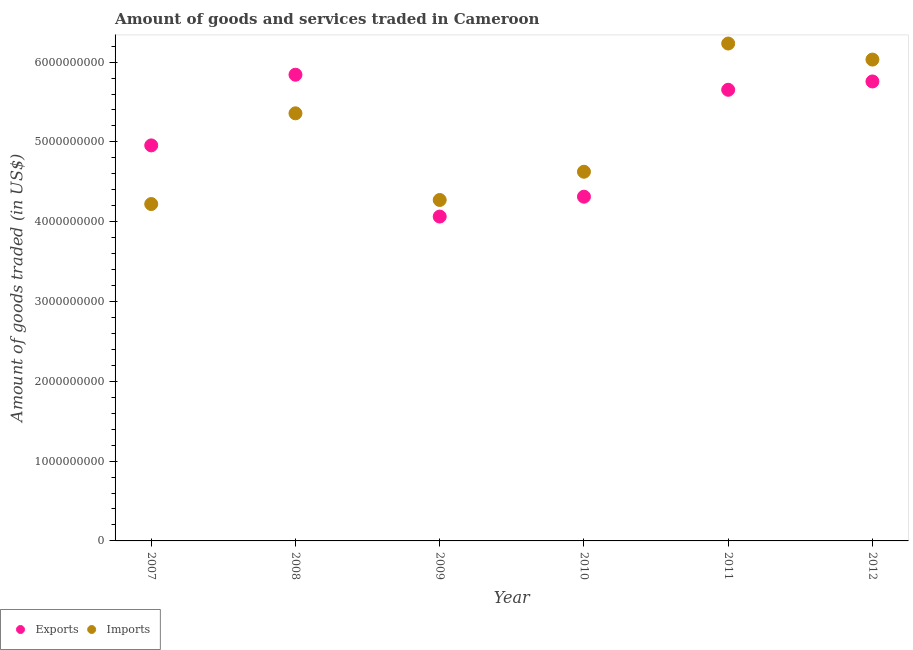How many different coloured dotlines are there?
Offer a terse response. 2. Is the number of dotlines equal to the number of legend labels?
Keep it short and to the point. Yes. What is the amount of goods exported in 2008?
Provide a short and direct response. 5.84e+09. Across all years, what is the maximum amount of goods exported?
Ensure brevity in your answer.  5.84e+09. Across all years, what is the minimum amount of goods imported?
Give a very brief answer. 4.22e+09. What is the total amount of goods exported in the graph?
Make the answer very short. 3.06e+1. What is the difference between the amount of goods exported in 2010 and that in 2012?
Provide a succinct answer. -1.44e+09. What is the difference between the amount of goods imported in 2011 and the amount of goods exported in 2008?
Provide a succinct answer. 3.91e+08. What is the average amount of goods imported per year?
Provide a succinct answer. 5.12e+09. In the year 2010, what is the difference between the amount of goods exported and amount of goods imported?
Your answer should be very brief. -3.13e+08. What is the ratio of the amount of goods imported in 2008 to that in 2010?
Provide a succinct answer. 1.16. Is the amount of goods imported in 2009 less than that in 2010?
Offer a very short reply. Yes. What is the difference between the highest and the second highest amount of goods exported?
Provide a succinct answer. 8.45e+07. What is the difference between the highest and the lowest amount of goods imported?
Offer a terse response. 2.01e+09. In how many years, is the amount of goods exported greater than the average amount of goods exported taken over all years?
Your answer should be compact. 3. Is the sum of the amount of goods imported in 2008 and 2011 greater than the maximum amount of goods exported across all years?
Make the answer very short. Yes. Where does the legend appear in the graph?
Provide a short and direct response. Bottom left. How are the legend labels stacked?
Your answer should be very brief. Horizontal. What is the title of the graph?
Ensure brevity in your answer.  Amount of goods and services traded in Cameroon. What is the label or title of the X-axis?
Provide a succinct answer. Year. What is the label or title of the Y-axis?
Provide a succinct answer. Amount of goods traded (in US$). What is the Amount of goods traded (in US$) in Exports in 2007?
Your answer should be compact. 4.96e+09. What is the Amount of goods traded (in US$) in Imports in 2007?
Keep it short and to the point. 4.22e+09. What is the Amount of goods traded (in US$) of Exports in 2008?
Give a very brief answer. 5.84e+09. What is the Amount of goods traded (in US$) in Imports in 2008?
Make the answer very short. 5.36e+09. What is the Amount of goods traded (in US$) of Exports in 2009?
Offer a very short reply. 4.06e+09. What is the Amount of goods traded (in US$) in Imports in 2009?
Provide a succinct answer. 4.27e+09. What is the Amount of goods traded (in US$) of Exports in 2010?
Make the answer very short. 4.31e+09. What is the Amount of goods traded (in US$) in Imports in 2010?
Offer a very short reply. 4.63e+09. What is the Amount of goods traded (in US$) in Exports in 2011?
Your answer should be very brief. 5.65e+09. What is the Amount of goods traded (in US$) of Imports in 2011?
Provide a succinct answer. 6.23e+09. What is the Amount of goods traded (in US$) in Exports in 2012?
Keep it short and to the point. 5.76e+09. What is the Amount of goods traded (in US$) in Imports in 2012?
Your response must be concise. 6.03e+09. Across all years, what is the maximum Amount of goods traded (in US$) in Exports?
Provide a short and direct response. 5.84e+09. Across all years, what is the maximum Amount of goods traded (in US$) of Imports?
Your answer should be very brief. 6.23e+09. Across all years, what is the minimum Amount of goods traded (in US$) of Exports?
Your answer should be very brief. 4.06e+09. Across all years, what is the minimum Amount of goods traded (in US$) in Imports?
Your answer should be very brief. 4.22e+09. What is the total Amount of goods traded (in US$) of Exports in the graph?
Offer a very short reply. 3.06e+1. What is the total Amount of goods traded (in US$) in Imports in the graph?
Make the answer very short. 3.07e+1. What is the difference between the Amount of goods traded (in US$) in Exports in 2007 and that in 2008?
Your answer should be very brief. -8.86e+08. What is the difference between the Amount of goods traded (in US$) in Imports in 2007 and that in 2008?
Ensure brevity in your answer.  -1.14e+09. What is the difference between the Amount of goods traded (in US$) of Exports in 2007 and that in 2009?
Provide a succinct answer. 8.92e+08. What is the difference between the Amount of goods traded (in US$) in Imports in 2007 and that in 2009?
Provide a succinct answer. -5.08e+07. What is the difference between the Amount of goods traded (in US$) in Exports in 2007 and that in 2010?
Your answer should be very brief. 6.43e+08. What is the difference between the Amount of goods traded (in US$) in Imports in 2007 and that in 2010?
Provide a short and direct response. -4.05e+08. What is the difference between the Amount of goods traded (in US$) of Exports in 2007 and that in 2011?
Provide a short and direct response. -6.97e+08. What is the difference between the Amount of goods traded (in US$) in Imports in 2007 and that in 2011?
Keep it short and to the point. -2.01e+09. What is the difference between the Amount of goods traded (in US$) in Exports in 2007 and that in 2012?
Provide a short and direct response. -8.01e+08. What is the difference between the Amount of goods traded (in US$) of Imports in 2007 and that in 2012?
Your answer should be compact. -1.81e+09. What is the difference between the Amount of goods traded (in US$) of Exports in 2008 and that in 2009?
Your answer should be compact. 1.78e+09. What is the difference between the Amount of goods traded (in US$) of Imports in 2008 and that in 2009?
Your response must be concise. 1.09e+09. What is the difference between the Amount of goods traded (in US$) in Exports in 2008 and that in 2010?
Your response must be concise. 1.53e+09. What is the difference between the Amount of goods traded (in US$) in Imports in 2008 and that in 2010?
Your answer should be very brief. 7.32e+08. What is the difference between the Amount of goods traded (in US$) of Exports in 2008 and that in 2011?
Your response must be concise. 1.89e+08. What is the difference between the Amount of goods traded (in US$) of Imports in 2008 and that in 2011?
Offer a very short reply. -8.75e+08. What is the difference between the Amount of goods traded (in US$) in Exports in 2008 and that in 2012?
Keep it short and to the point. 8.45e+07. What is the difference between the Amount of goods traded (in US$) of Imports in 2008 and that in 2012?
Make the answer very short. -6.73e+08. What is the difference between the Amount of goods traded (in US$) in Exports in 2009 and that in 2010?
Make the answer very short. -2.49e+08. What is the difference between the Amount of goods traded (in US$) in Imports in 2009 and that in 2010?
Offer a very short reply. -3.54e+08. What is the difference between the Amount of goods traded (in US$) in Exports in 2009 and that in 2011?
Your answer should be very brief. -1.59e+09. What is the difference between the Amount of goods traded (in US$) in Imports in 2009 and that in 2011?
Make the answer very short. -1.96e+09. What is the difference between the Amount of goods traded (in US$) of Exports in 2009 and that in 2012?
Your answer should be compact. -1.69e+09. What is the difference between the Amount of goods traded (in US$) of Imports in 2009 and that in 2012?
Your answer should be very brief. -1.76e+09. What is the difference between the Amount of goods traded (in US$) in Exports in 2010 and that in 2011?
Your response must be concise. -1.34e+09. What is the difference between the Amount of goods traded (in US$) of Imports in 2010 and that in 2011?
Provide a short and direct response. -1.61e+09. What is the difference between the Amount of goods traded (in US$) of Exports in 2010 and that in 2012?
Make the answer very short. -1.44e+09. What is the difference between the Amount of goods traded (in US$) in Imports in 2010 and that in 2012?
Provide a short and direct response. -1.41e+09. What is the difference between the Amount of goods traded (in US$) of Exports in 2011 and that in 2012?
Your answer should be compact. -1.04e+08. What is the difference between the Amount of goods traded (in US$) in Imports in 2011 and that in 2012?
Offer a very short reply. 2.01e+08. What is the difference between the Amount of goods traded (in US$) of Exports in 2007 and the Amount of goods traded (in US$) of Imports in 2008?
Provide a short and direct response. -4.02e+08. What is the difference between the Amount of goods traded (in US$) in Exports in 2007 and the Amount of goods traded (in US$) in Imports in 2009?
Provide a short and direct response. 6.84e+08. What is the difference between the Amount of goods traded (in US$) of Exports in 2007 and the Amount of goods traded (in US$) of Imports in 2010?
Your answer should be compact. 3.30e+08. What is the difference between the Amount of goods traded (in US$) in Exports in 2007 and the Amount of goods traded (in US$) in Imports in 2011?
Keep it short and to the point. -1.28e+09. What is the difference between the Amount of goods traded (in US$) in Exports in 2007 and the Amount of goods traded (in US$) in Imports in 2012?
Offer a terse response. -1.08e+09. What is the difference between the Amount of goods traded (in US$) of Exports in 2008 and the Amount of goods traded (in US$) of Imports in 2009?
Offer a very short reply. 1.57e+09. What is the difference between the Amount of goods traded (in US$) of Exports in 2008 and the Amount of goods traded (in US$) of Imports in 2010?
Your answer should be compact. 1.22e+09. What is the difference between the Amount of goods traded (in US$) of Exports in 2008 and the Amount of goods traded (in US$) of Imports in 2011?
Provide a succinct answer. -3.91e+08. What is the difference between the Amount of goods traded (in US$) of Exports in 2008 and the Amount of goods traded (in US$) of Imports in 2012?
Your response must be concise. -1.90e+08. What is the difference between the Amount of goods traded (in US$) in Exports in 2009 and the Amount of goods traded (in US$) in Imports in 2010?
Provide a short and direct response. -5.62e+08. What is the difference between the Amount of goods traded (in US$) of Exports in 2009 and the Amount of goods traded (in US$) of Imports in 2011?
Your answer should be compact. -2.17e+09. What is the difference between the Amount of goods traded (in US$) in Exports in 2009 and the Amount of goods traded (in US$) in Imports in 2012?
Provide a succinct answer. -1.97e+09. What is the difference between the Amount of goods traded (in US$) in Exports in 2010 and the Amount of goods traded (in US$) in Imports in 2011?
Your answer should be very brief. -1.92e+09. What is the difference between the Amount of goods traded (in US$) in Exports in 2010 and the Amount of goods traded (in US$) in Imports in 2012?
Provide a succinct answer. -1.72e+09. What is the difference between the Amount of goods traded (in US$) of Exports in 2011 and the Amount of goods traded (in US$) of Imports in 2012?
Offer a terse response. -3.78e+08. What is the average Amount of goods traded (in US$) in Exports per year?
Give a very brief answer. 5.10e+09. What is the average Amount of goods traded (in US$) of Imports per year?
Your answer should be very brief. 5.12e+09. In the year 2007, what is the difference between the Amount of goods traded (in US$) of Exports and Amount of goods traded (in US$) of Imports?
Make the answer very short. 7.35e+08. In the year 2008, what is the difference between the Amount of goods traded (in US$) of Exports and Amount of goods traded (in US$) of Imports?
Provide a succinct answer. 4.84e+08. In the year 2009, what is the difference between the Amount of goods traded (in US$) of Exports and Amount of goods traded (in US$) of Imports?
Ensure brevity in your answer.  -2.08e+08. In the year 2010, what is the difference between the Amount of goods traded (in US$) in Exports and Amount of goods traded (in US$) in Imports?
Offer a terse response. -3.13e+08. In the year 2011, what is the difference between the Amount of goods traded (in US$) of Exports and Amount of goods traded (in US$) of Imports?
Ensure brevity in your answer.  -5.80e+08. In the year 2012, what is the difference between the Amount of goods traded (in US$) in Exports and Amount of goods traded (in US$) in Imports?
Your response must be concise. -2.74e+08. What is the ratio of the Amount of goods traded (in US$) in Exports in 2007 to that in 2008?
Offer a very short reply. 0.85. What is the ratio of the Amount of goods traded (in US$) of Imports in 2007 to that in 2008?
Give a very brief answer. 0.79. What is the ratio of the Amount of goods traded (in US$) of Exports in 2007 to that in 2009?
Provide a succinct answer. 1.22. What is the ratio of the Amount of goods traded (in US$) in Exports in 2007 to that in 2010?
Your answer should be compact. 1.15. What is the ratio of the Amount of goods traded (in US$) in Imports in 2007 to that in 2010?
Your answer should be compact. 0.91. What is the ratio of the Amount of goods traded (in US$) in Exports in 2007 to that in 2011?
Offer a very short reply. 0.88. What is the ratio of the Amount of goods traded (in US$) of Imports in 2007 to that in 2011?
Offer a very short reply. 0.68. What is the ratio of the Amount of goods traded (in US$) in Exports in 2007 to that in 2012?
Make the answer very short. 0.86. What is the ratio of the Amount of goods traded (in US$) in Imports in 2007 to that in 2012?
Offer a terse response. 0.7. What is the ratio of the Amount of goods traded (in US$) of Exports in 2008 to that in 2009?
Give a very brief answer. 1.44. What is the ratio of the Amount of goods traded (in US$) in Imports in 2008 to that in 2009?
Your response must be concise. 1.25. What is the ratio of the Amount of goods traded (in US$) of Exports in 2008 to that in 2010?
Keep it short and to the point. 1.35. What is the ratio of the Amount of goods traded (in US$) of Imports in 2008 to that in 2010?
Your answer should be compact. 1.16. What is the ratio of the Amount of goods traded (in US$) of Exports in 2008 to that in 2011?
Offer a terse response. 1.03. What is the ratio of the Amount of goods traded (in US$) of Imports in 2008 to that in 2011?
Ensure brevity in your answer.  0.86. What is the ratio of the Amount of goods traded (in US$) in Exports in 2008 to that in 2012?
Your answer should be compact. 1.01. What is the ratio of the Amount of goods traded (in US$) of Imports in 2008 to that in 2012?
Ensure brevity in your answer.  0.89. What is the ratio of the Amount of goods traded (in US$) of Exports in 2009 to that in 2010?
Your response must be concise. 0.94. What is the ratio of the Amount of goods traded (in US$) of Imports in 2009 to that in 2010?
Your response must be concise. 0.92. What is the ratio of the Amount of goods traded (in US$) of Exports in 2009 to that in 2011?
Make the answer very short. 0.72. What is the ratio of the Amount of goods traded (in US$) of Imports in 2009 to that in 2011?
Provide a succinct answer. 0.69. What is the ratio of the Amount of goods traded (in US$) in Exports in 2009 to that in 2012?
Give a very brief answer. 0.71. What is the ratio of the Amount of goods traded (in US$) in Imports in 2009 to that in 2012?
Offer a terse response. 0.71. What is the ratio of the Amount of goods traded (in US$) of Exports in 2010 to that in 2011?
Your response must be concise. 0.76. What is the ratio of the Amount of goods traded (in US$) of Imports in 2010 to that in 2011?
Your answer should be compact. 0.74. What is the ratio of the Amount of goods traded (in US$) in Exports in 2010 to that in 2012?
Provide a short and direct response. 0.75. What is the ratio of the Amount of goods traded (in US$) of Imports in 2010 to that in 2012?
Make the answer very short. 0.77. What is the ratio of the Amount of goods traded (in US$) in Exports in 2011 to that in 2012?
Offer a very short reply. 0.98. What is the ratio of the Amount of goods traded (in US$) in Imports in 2011 to that in 2012?
Provide a short and direct response. 1.03. What is the difference between the highest and the second highest Amount of goods traded (in US$) in Exports?
Provide a succinct answer. 8.45e+07. What is the difference between the highest and the second highest Amount of goods traded (in US$) of Imports?
Your answer should be compact. 2.01e+08. What is the difference between the highest and the lowest Amount of goods traded (in US$) of Exports?
Provide a short and direct response. 1.78e+09. What is the difference between the highest and the lowest Amount of goods traded (in US$) of Imports?
Provide a short and direct response. 2.01e+09. 